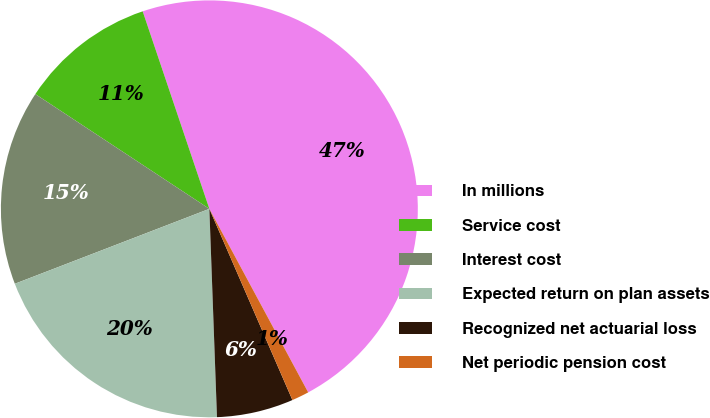<chart> <loc_0><loc_0><loc_500><loc_500><pie_chart><fcel>In millions<fcel>Service cost<fcel>Interest cost<fcel>Expected return on plan assets<fcel>Recognized net actuarial loss<fcel>Net periodic pension cost<nl><fcel>47.32%<fcel>10.54%<fcel>15.13%<fcel>19.73%<fcel>5.94%<fcel>1.34%<nl></chart> 